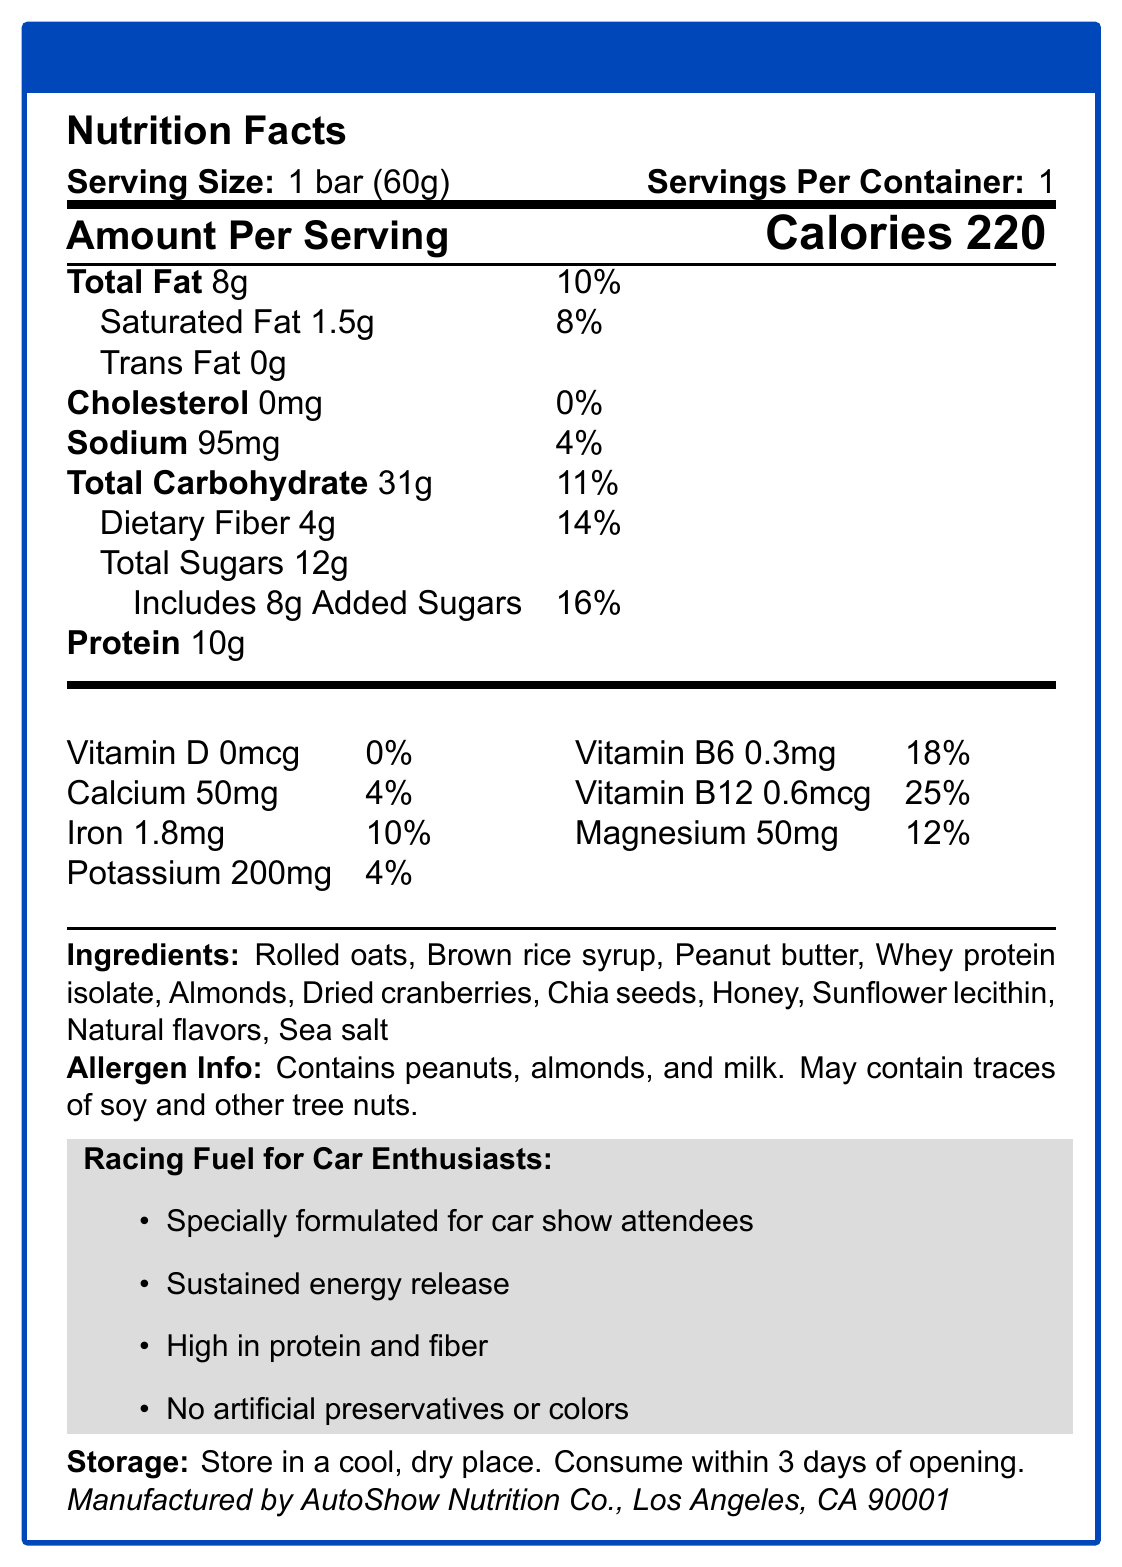what is the serving size? The serving size is specified at the top of the nutrition facts section on the document.
Answer: 1 bar (60g) how many calories are in one serving? The number of calories per serving is clearly mentioned right below the serving size information in large text.
Answer: 220 what is the amount of dietary fiber per serving? The dietary fiber amount is listed under the total carbohydrate section in the nutrition facts.
Answer: 4g does the RallyBoost Energy Bar contain any Trans Fat? The document lists 'Trans Fat 0g', indicating that there is no trans fat in the bar.
Answer: No what kind of allergens are present in the RallyBoost Energy Bar? This information is clearly provided in the allergen info section at the bottom.
Answer: Contains peanuts, almonds, and milk. May contain traces of soy and other tree nuts. how many grams of added sugars are in the bar? The amount of added sugars is explicitly given under the total sugars value in the nutrition facts.
Answer: 8g which vitamin has the highest percentage of daily value? A. Vitamin D B. Vitamin B6 C. Vitamin B12 D. Calcium The document lists Vitamin B12 with a daily value of 25%, which is higher than the other vitamins and minerals.
Answer: C. Vitamin B12 where should the RallyBoost Energy Bar be stored? A. In a refrigerator B. In a cool, dry place C. At room temperature D. In a wet place The storage instructions at the bottom mention that the bar should be stored in a cool, dry place.
Answer: B. In a cool, dry place is the RallyBoost Energy Bar high in protein? The bar contains 10g of protein per serving, and the marketing claims point out "High in protein and fiber."
Answer: Yes describe the main idea of the document. The document provides detailed nutritional and ingredient information for the RallyBoost Energy Bar, including its benefits and storage instructions, emphasizing its suitability for car show attendees.
Answer: The document is a nutrition facts label for RallyBoost Energy Bar, designed for car show attendees. It details the serving size, calories, and nutritional content including fats, carbohydrates, protein, vitamins, and minerals. It also lists ingredients, allergen information, marketing claims, and storage instructions, with the product being manufactured by AutoShow Nutrition Co. what is the daily value percentage for magnesium? The percentage daily value for magnesium is listed in the second column of the detailed nutrition facts under vitamins and minerals.
Answer: 12% what company manufactures the RallyBoost Energy Bar? The manufacturer’s name and location are provided at the bottom of the document.
Answer: AutoShow Nutrition Co., Los Angeles, CA 90001 how many bar(s) are there in one container? The servings per container is mentioned as 1 at the top of the nutrition facts label.
Answer: 1 can I find out the price of the RallyBoost Energy Bar from this document? The document focuses on nutritional facts, ingredients, marketing claims, and storage but does not provide any pricing information.
Answer: Not enough information what kind of dietary lifestyle might benefit from consuming the RallyBoost Energy Bar? The document claims the bar is specially formulated for car show attendees, emphasizes sustained energy release, and promotes high protein and fiber content suitable for those avoiding artificial ingredients.
Answer: Those looking for high protein and fiber snacks with no artificial preservatives or colors; particularly car show attendees needing sustained energy. 